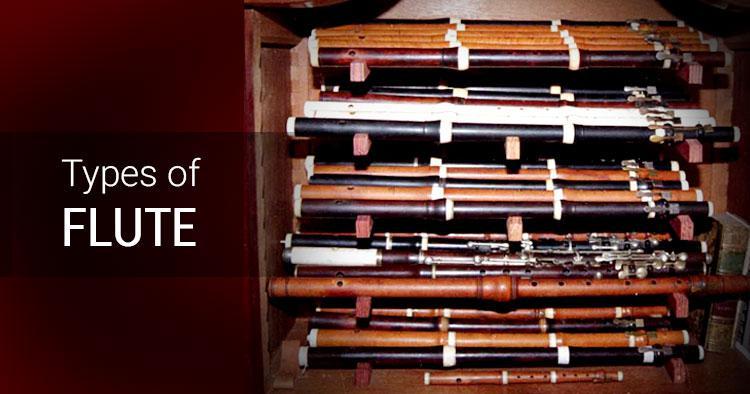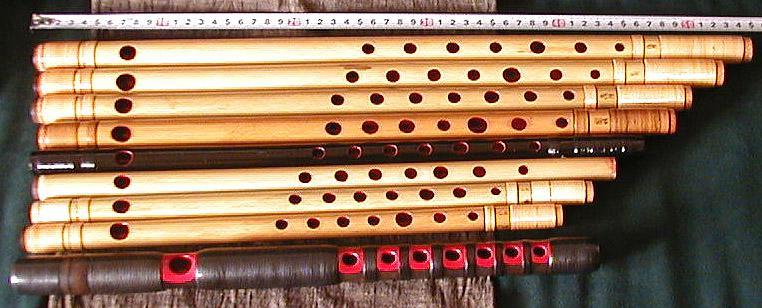The first image is the image on the left, the second image is the image on the right. Examine the images to the left and right. Is the description "An image contains various flute like instruments with an all white background." accurate? Answer yes or no. No. The first image is the image on the left, the second image is the image on the right. For the images displayed, is the sentence "There are at least  15 flutes that are white, black or brown sitting on  multiple shelves." factually correct? Answer yes or no. Yes. 